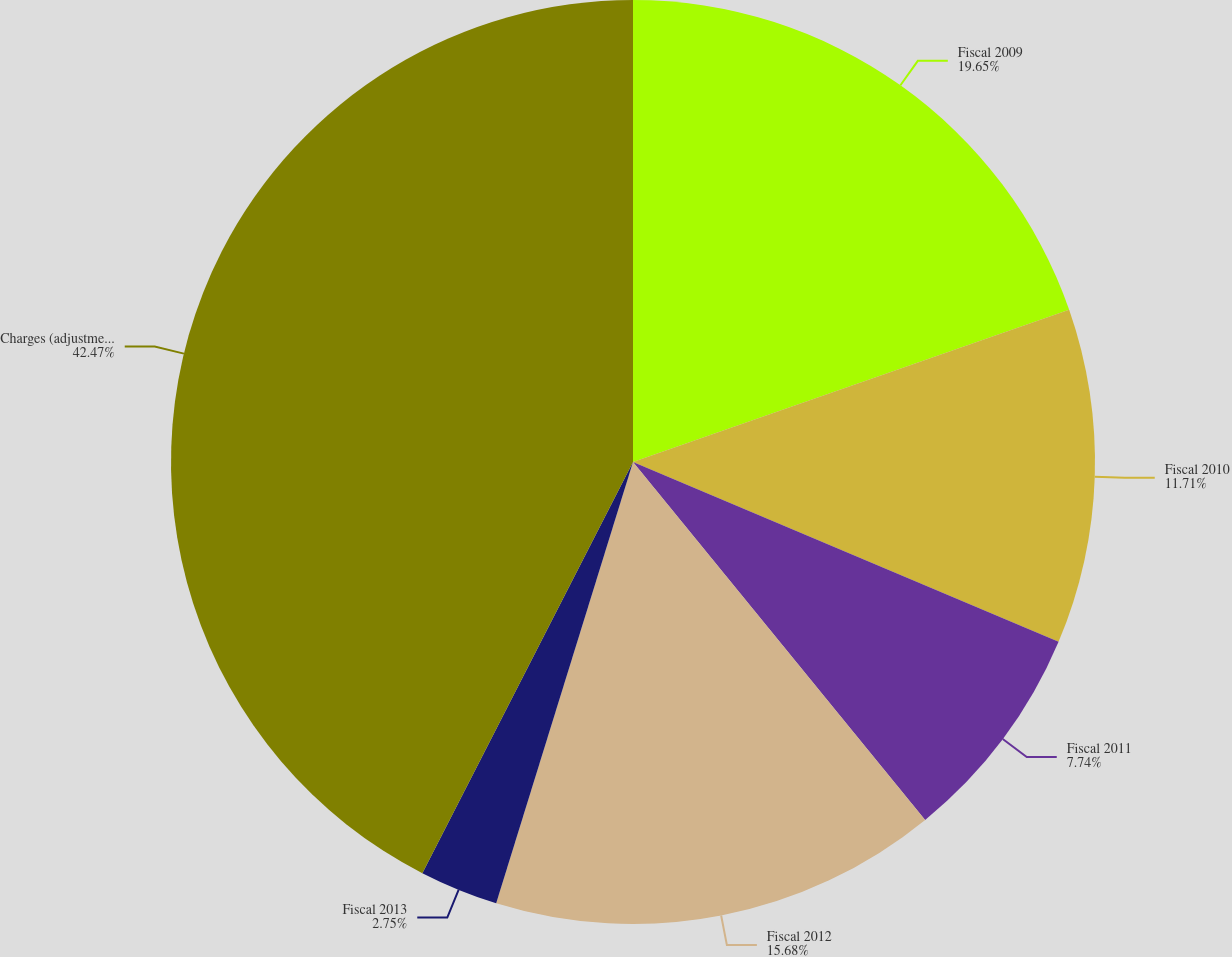<chart> <loc_0><loc_0><loc_500><loc_500><pie_chart><fcel>Fiscal 2009<fcel>Fiscal 2010<fcel>Fiscal 2011<fcel>Fiscal 2012<fcel>Fiscal 2013<fcel>Charges (adjustments) recorded<nl><fcel>19.65%<fcel>11.71%<fcel>7.74%<fcel>15.68%<fcel>2.75%<fcel>42.46%<nl></chart> 